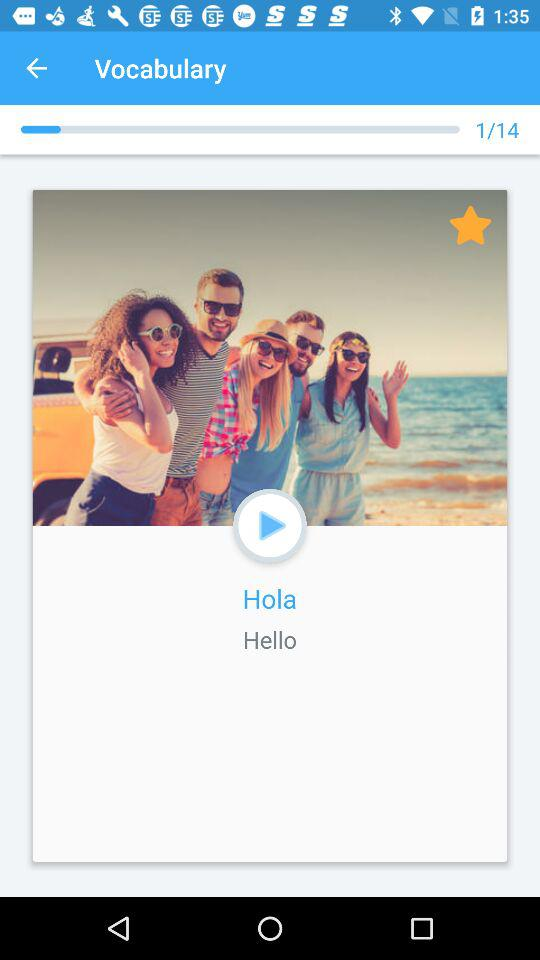What is the total number of stages? The total number of stages is 14. 